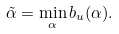Convert formula to latex. <formula><loc_0><loc_0><loc_500><loc_500>\tilde { \alpha } = \min _ { \alpha } b _ { u } ( \alpha ) .</formula> 